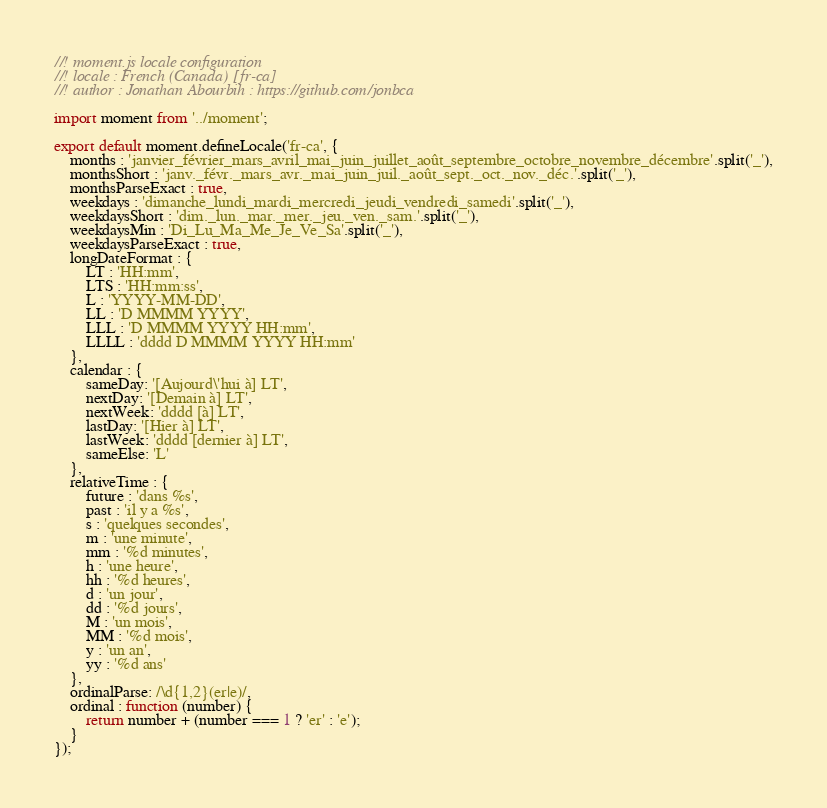<code> <loc_0><loc_0><loc_500><loc_500><_JavaScript_>//! moment.js locale configuration
//! locale : French (Canada) [fr-ca]
//! author : Jonathan Abourbih : https://github.com/jonbca

import moment from '../moment';

export default moment.defineLocale('fr-ca', {
    months : 'janvier_février_mars_avril_mai_juin_juillet_août_septembre_octobre_novembre_décembre'.split('_'),
    monthsShort : 'janv._févr._mars_avr._mai_juin_juil._août_sept._oct._nov._déc.'.split('_'),
    monthsParseExact : true,
    weekdays : 'dimanche_lundi_mardi_mercredi_jeudi_vendredi_samedi'.split('_'),
    weekdaysShort : 'dim._lun._mar._mer._jeu._ven._sam.'.split('_'),
    weekdaysMin : 'Di_Lu_Ma_Me_Je_Ve_Sa'.split('_'),
    weekdaysParseExact : true,
    longDateFormat : {
        LT : 'HH:mm',
        LTS : 'HH:mm:ss',
        L : 'YYYY-MM-DD',
        LL : 'D MMMM YYYY',
        LLL : 'D MMMM YYYY HH:mm',
        LLLL : 'dddd D MMMM YYYY HH:mm'
    },
    calendar : {
        sameDay: '[Aujourd\'hui à] LT',
        nextDay: '[Demain à] LT',
        nextWeek: 'dddd [à] LT',
        lastDay: '[Hier à] LT',
        lastWeek: 'dddd [dernier à] LT',
        sameElse: 'L'
    },
    relativeTime : {
        future : 'dans %s',
        past : 'il y a %s',
        s : 'quelques secondes',
        m : 'une minute',
        mm : '%d minutes',
        h : 'une heure',
        hh : '%d heures',
        d : 'un jour',
        dd : '%d jours',
        M : 'un mois',
        MM : '%d mois',
        y : 'un an',
        yy : '%d ans'
    },
    ordinalParse: /\d{1,2}(er|e)/,
    ordinal : function (number) {
        return number + (number === 1 ? 'er' : 'e');
    }
});

</code> 